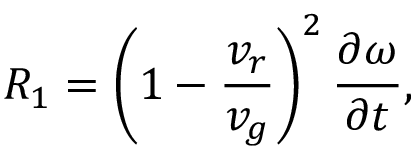<formula> <loc_0><loc_0><loc_500><loc_500>R _ { 1 } = \left ( 1 - \frac { v _ { r } } { v _ { g } } \right ) ^ { 2 } \frac { \partial \omega } { \partial t } ,</formula> 